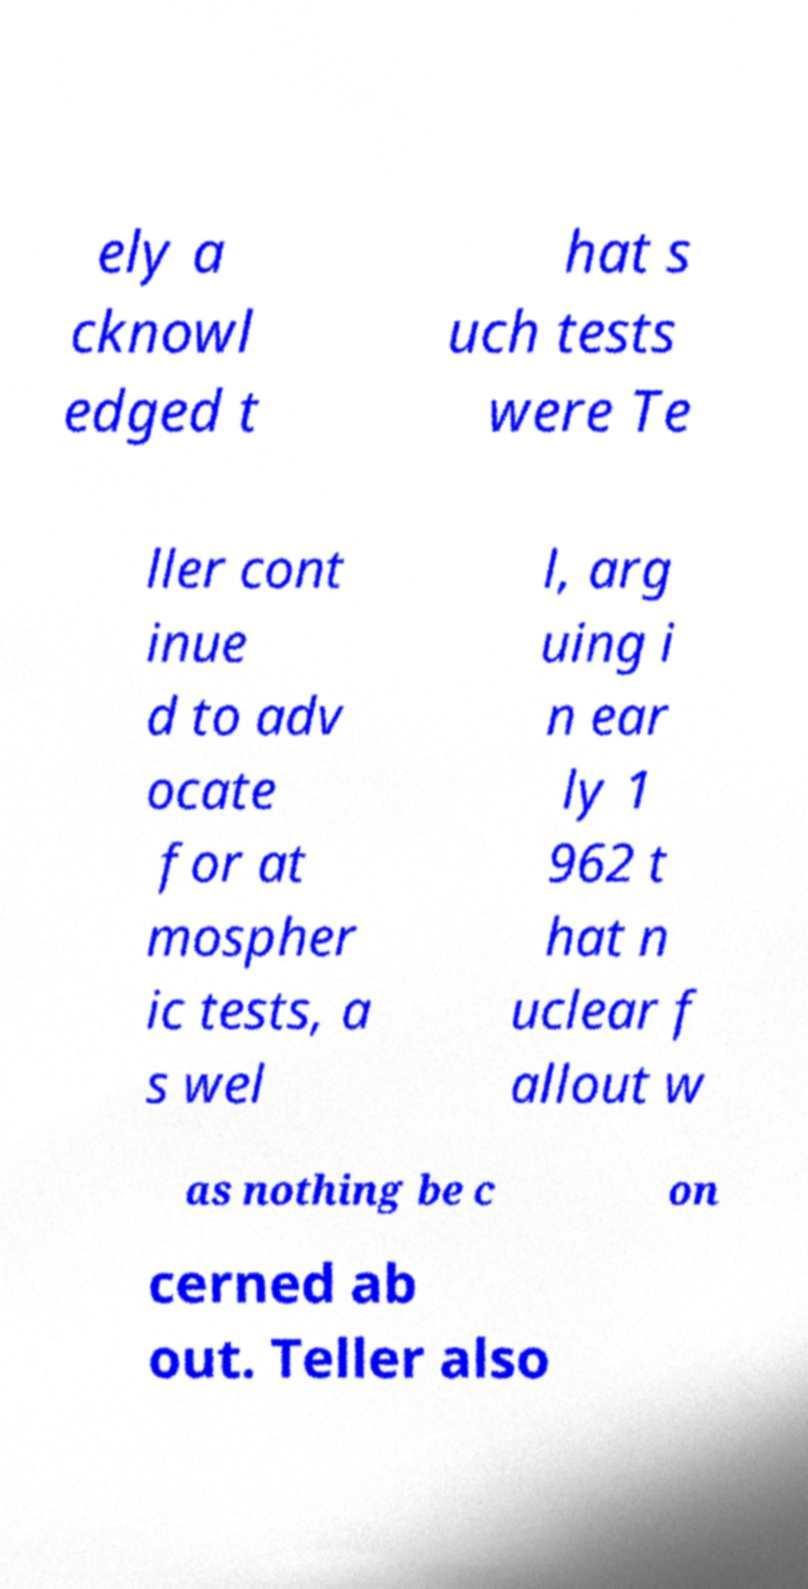Can you read and provide the text displayed in the image?This photo seems to have some interesting text. Can you extract and type it out for me? ely a cknowl edged t hat s uch tests were Te ller cont inue d to adv ocate for at mospher ic tests, a s wel l, arg uing i n ear ly 1 962 t hat n uclear f allout w as nothing be c on cerned ab out. Teller also 